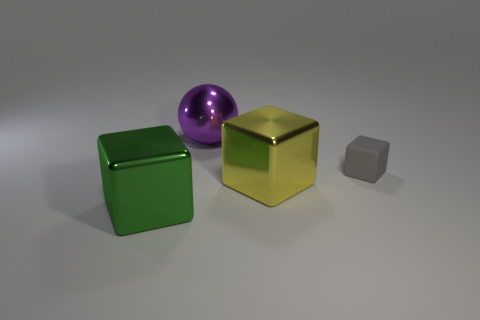Is there anything else that has the same material as the gray object?
Your answer should be very brief. No. What size is the gray matte block?
Provide a short and direct response. Small. Is there another small gray thing that has the same shape as the rubber thing?
Your response must be concise. No. What number of objects are large green shiny blocks or large things that are behind the gray thing?
Offer a very short reply. 2. The large object that is on the left side of the purple thing is what color?
Ensure brevity in your answer.  Green. There is a gray thing that is to the right of the purple metal object; is it the same size as the thing behind the gray cube?
Your answer should be compact. No. Is there a metallic block of the same size as the purple object?
Give a very brief answer. Yes. There is a large shiny block behind the big green cube; what number of purple metal spheres are in front of it?
Provide a short and direct response. 0. What material is the yellow object?
Your response must be concise. Metal. How many big metallic spheres are on the left side of the green metallic block?
Make the answer very short. 0. 